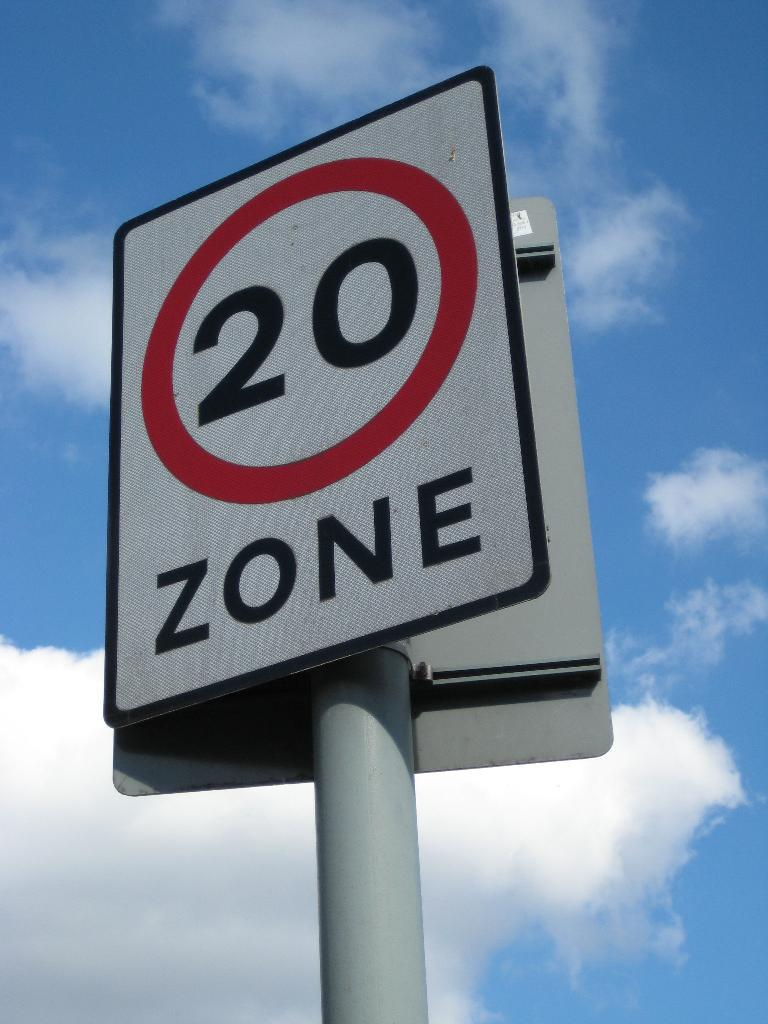<image>
Share a concise interpretation of the image provided. Road sign that says twenty zone on a white sign 